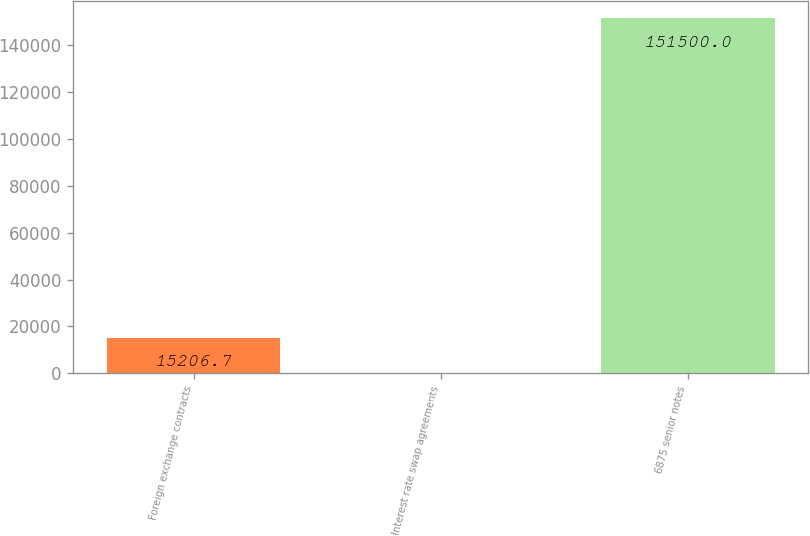Convert chart. <chart><loc_0><loc_0><loc_500><loc_500><bar_chart><fcel>Foreign exchange contracts<fcel>Interest rate swap agreements<fcel>6875 senior notes<nl><fcel>15206.7<fcel>63<fcel>151500<nl></chart> 